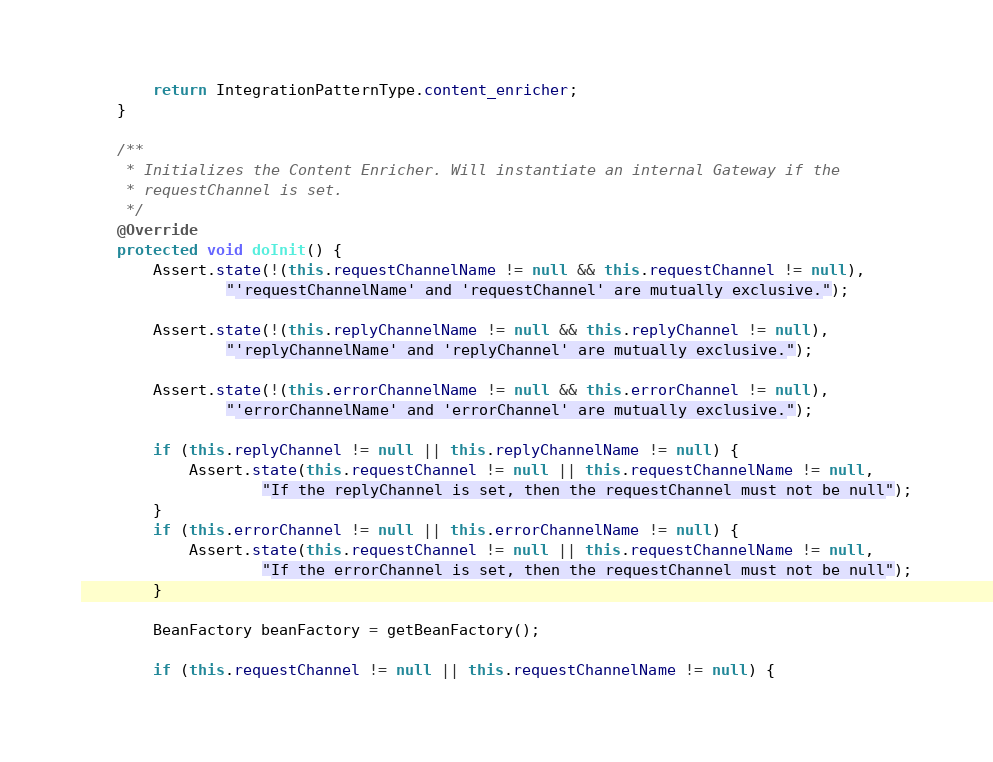Convert code to text. <code><loc_0><loc_0><loc_500><loc_500><_Java_>		return IntegrationPatternType.content_enricher;
	}

	/**
	 * Initializes the Content Enricher. Will instantiate an internal Gateway if the
	 * requestChannel is set.
	 */
	@Override
	protected void doInit() {
		Assert.state(!(this.requestChannelName != null && this.requestChannel != null),
				"'requestChannelName' and 'requestChannel' are mutually exclusive.");

		Assert.state(!(this.replyChannelName != null && this.replyChannel != null),
				"'replyChannelName' and 'replyChannel' are mutually exclusive.");

		Assert.state(!(this.errorChannelName != null && this.errorChannel != null),
				"'errorChannelName' and 'errorChannel' are mutually exclusive.");

		if (this.replyChannel != null || this.replyChannelName != null) {
			Assert.state(this.requestChannel != null || this.requestChannelName != null,
					"If the replyChannel is set, then the requestChannel must not be null");
		}
		if (this.errorChannel != null || this.errorChannelName != null) {
			Assert.state(this.requestChannel != null || this.requestChannelName != null,
					"If the errorChannel is set, then the requestChannel must not be null");
		}

		BeanFactory beanFactory = getBeanFactory();

		if (this.requestChannel != null || this.requestChannelName != null) {</code> 